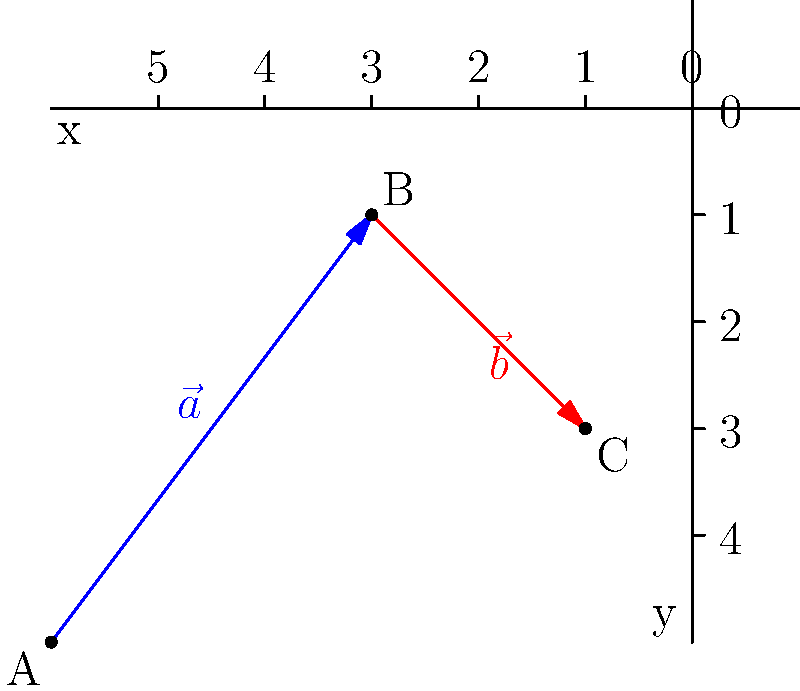A shepherd in the mountains near Kechüü village starts at point A and travels along vector $\vec{a}$ to point B, then along vector $\vec{b}$ to point C while herding sheep. If $\vec{a} = 3\hat{i} + 4\hat{j}$ and $\vec{b} = 2\hat{i} - 2\hat{j}$, what is the total distance traveled by the shepherd? To find the total distance traveled, we need to:

1. Calculate the magnitude of vector $\vec{a}$:
   $|\vec{a}| = \sqrt{3^2 + 4^2} = \sqrt{9 + 16} = \sqrt{25} = 5$ units

2. Calculate the magnitude of vector $\vec{b}$:
   $|\vec{b}| = \sqrt{2^2 + (-2)^2} = \sqrt{4 + 4} = \sqrt{8} = 2\sqrt{2}$ units

3. Sum the magnitudes to get the total distance:
   Total distance = $|\vec{a}| + |\vec{b}| = 5 + 2\sqrt{2}$ units

Therefore, the shepherd travels a total distance of $5 + 2\sqrt{2}$ units.
Answer: $5 + 2\sqrt{2}$ units 